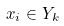Convert formula to latex. <formula><loc_0><loc_0><loc_500><loc_500>x _ { i } \in Y _ { k }</formula> 